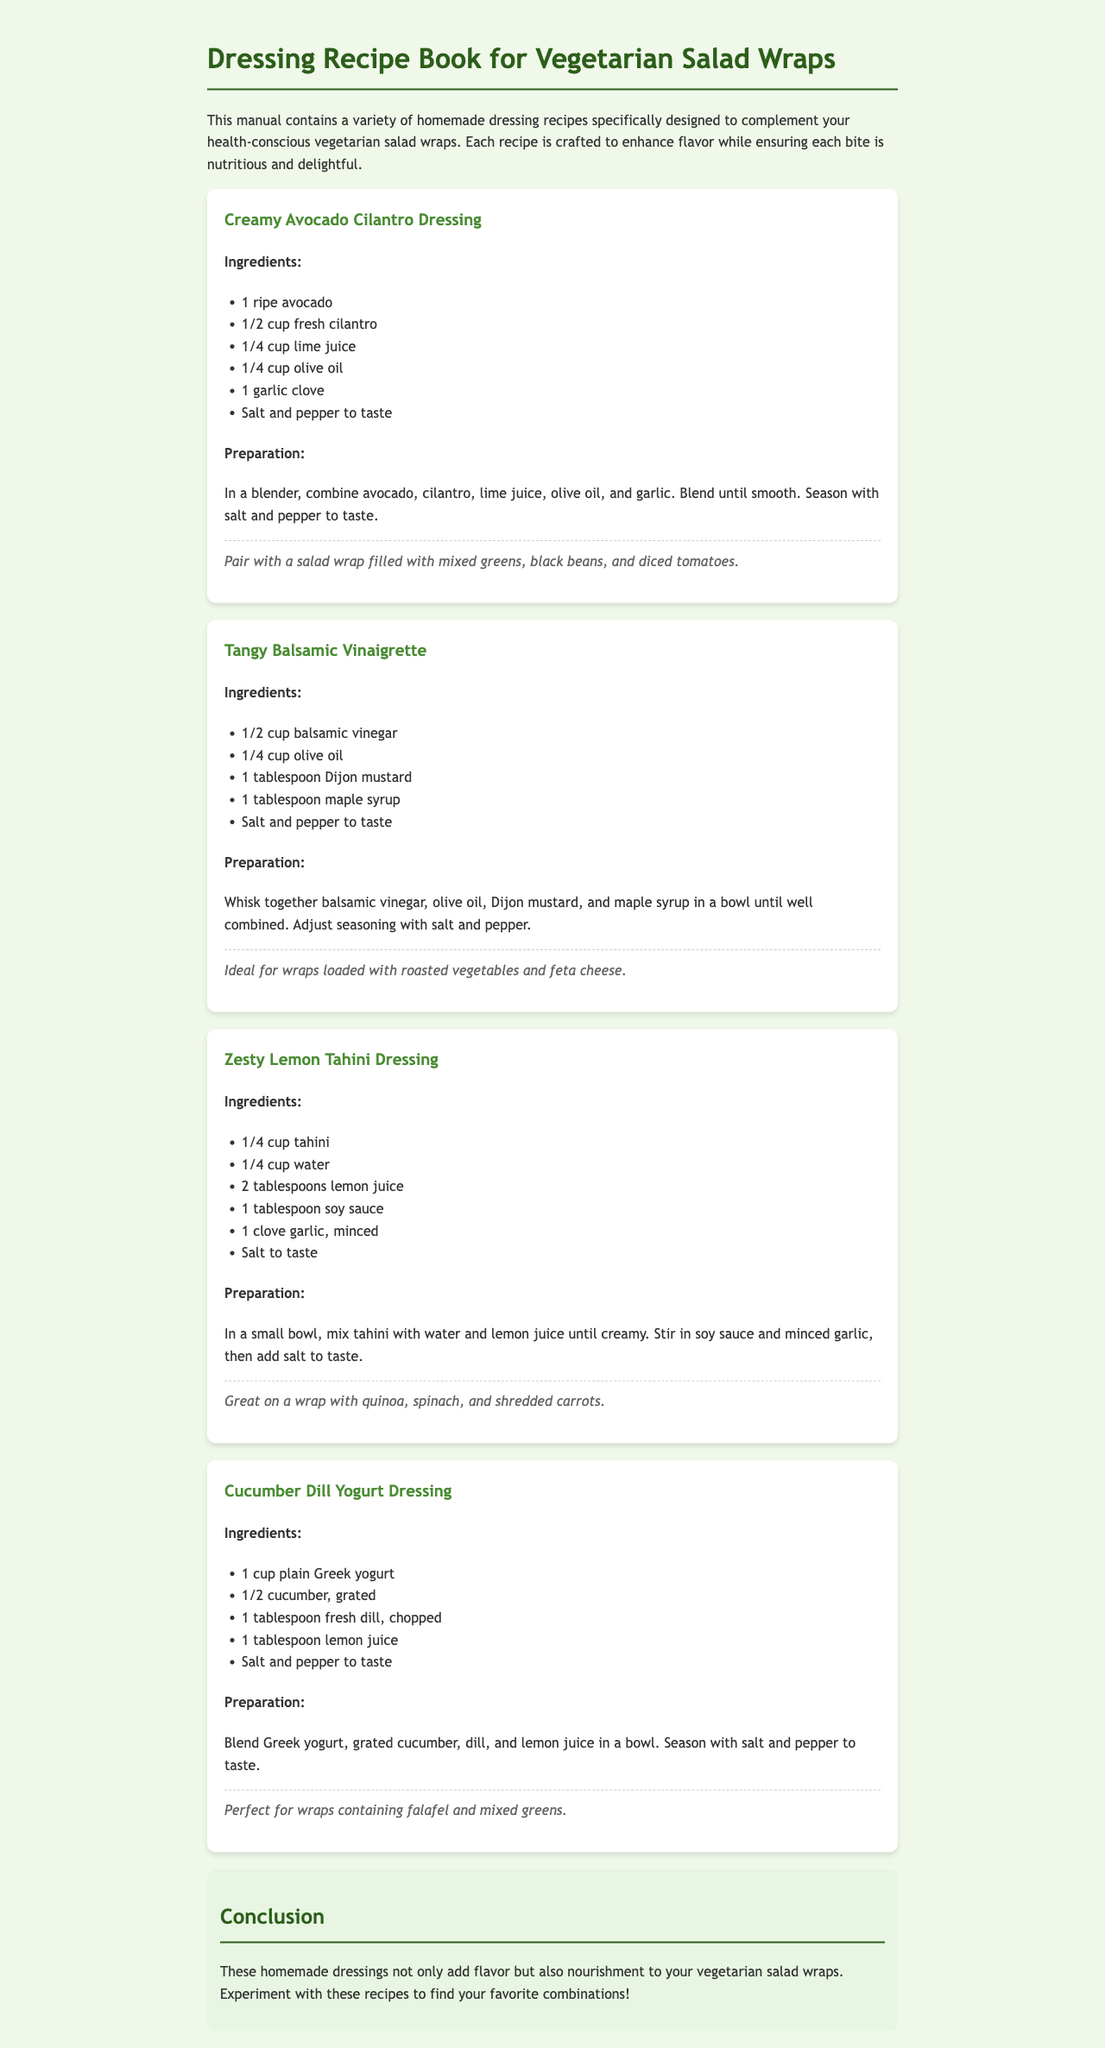What is the title of the manual? The title is provided in the header of the document, which highlights the main theme of the content.
Answer: Dressing Recipe Book for Vegetarian Salad Wraps How many dressing recipes are included in the manual? The manual contains a section for each recipe, which can be counted directly from the document's structured format.
Answer: Four Which dressing includes tahini as an ingredient? The document lists the ingredients of each dressing, allowing for the identification of specific ingredients within the recipes.
Answer: Zesty Lemon Tahini Dressing What is the serving suggestion for the Creamy Avocado Cilantro Dressing? Each recipe includes a section for serving suggestions, indicating how to best use the dressings with salad wraps.
Answer: Pair with a salad wrap filled with mixed greens, black beans, and diced tomatoes What is the main base ingredient of the Cucumber Dill Yogurt Dressing? The preparation details describe the core ingredients used in each dressing, helping identify their main components.
Answer: Greek yogurt How should the Tangy Balsamic Vinaigrette be mixed? The preparation section includes instructions on how to combine the ingredients for each dressing.
Answer: Whisk together What type of cuisine does the manual focus on? The thematic focus of the document centers around vegetarian dishes, which can be inferred from the title and content.
Answer: Vegetarian What is a suggested wrap filling for the Zesty Lemon Tahini Dressing? Each serving suggestion specifies the type of wrap fillings that complement the dressings, enhancing their flavors.
Answer: Quinoa, spinach, and shredded carrots 